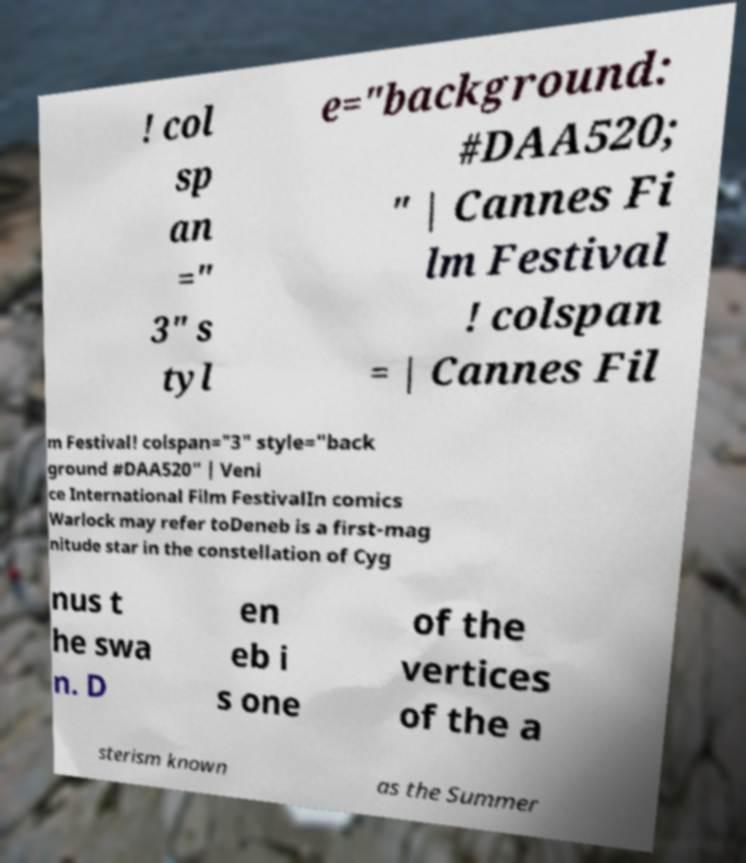Can you accurately transcribe the text from the provided image for me? ! col sp an =" 3" s tyl e="background: #DAA520; " | Cannes Fi lm Festival ! colspan = | Cannes Fil m Festival! colspan="3" style="back ground #DAA520" | Veni ce International Film FestivalIn comics Warlock may refer toDeneb is a first-mag nitude star in the constellation of Cyg nus t he swa n. D en eb i s one of the vertices of the a sterism known as the Summer 